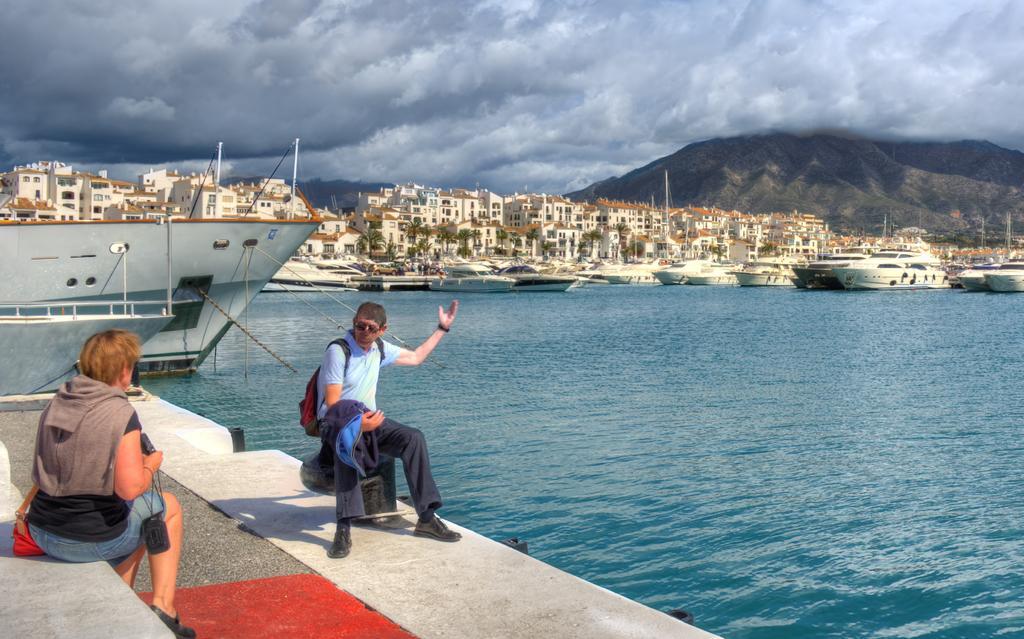How would you summarize this image in a sentence or two? In this image there are two persons sitting on the floor. Beside them there is water on which there are so many boats and ships. In the background there are so many buildings one beside the other. On the right side top there is a mountain. At the top there is a sky with the black clouds. On the left side there is a woman sitting on the wall. In front of her there is a red carpet. 